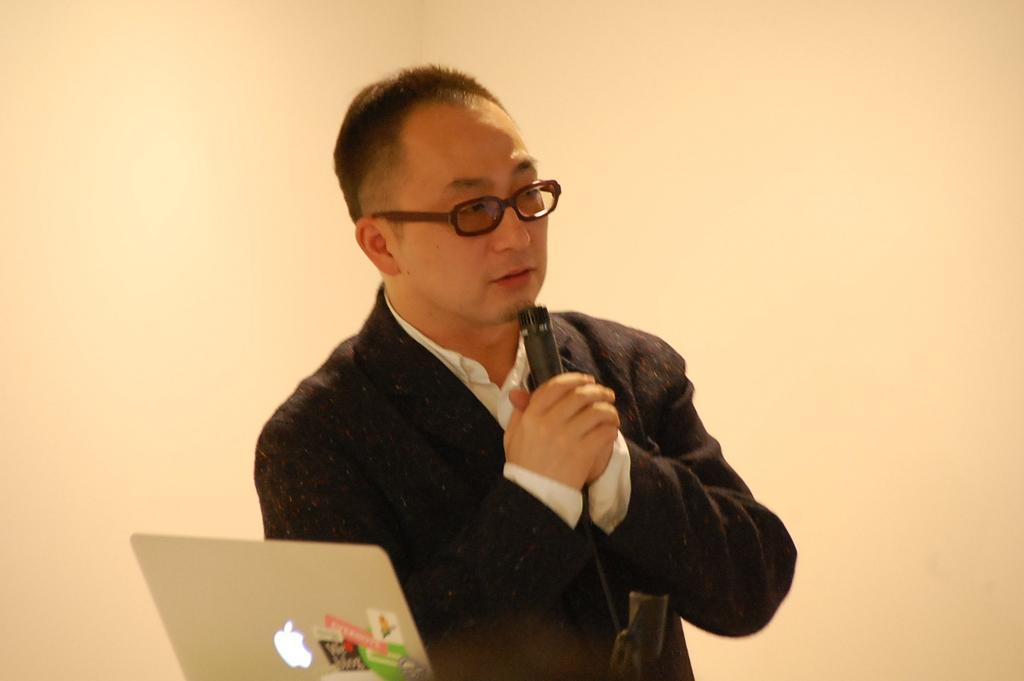What is the person in the image holding? The person is holding a microphone in the image. What electronic device can be seen in the foreground of the image? There is a laptop in the foreground of the image. What is visible in the background of the image? There is a wall in the background of the image. What type of engine can be seen in the image? There is no engine present in the image. Is there a bag visible in the image? The provided facts do not mention a bag, so it cannot be confirmed if one is present in the image. 